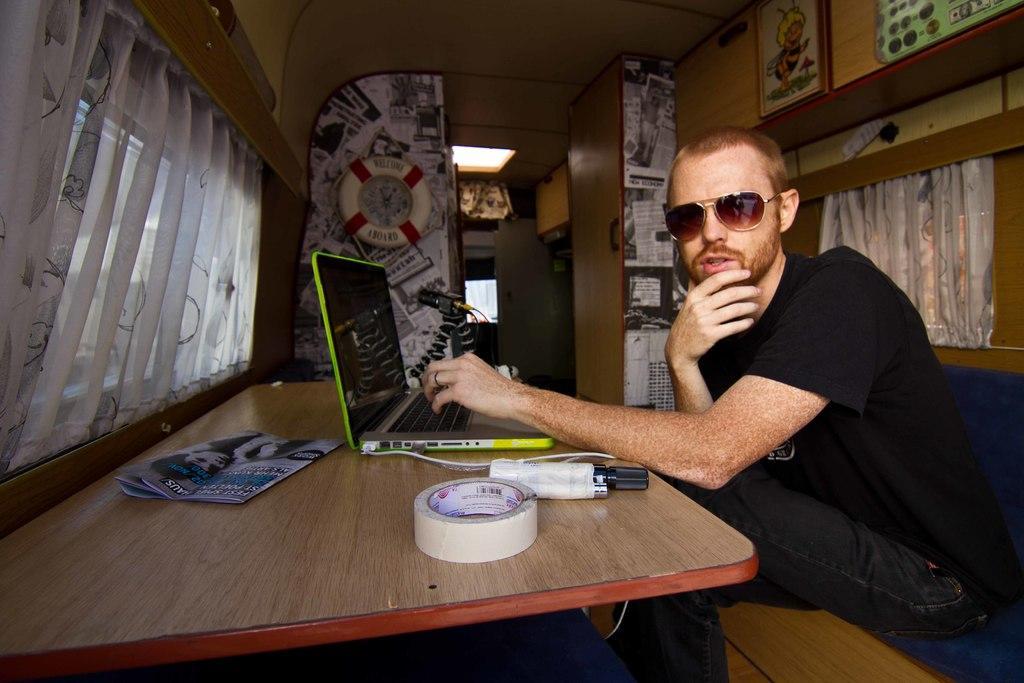How would you summarize this image in a sentence or two? In this picture there is a person wearing black T-shirt is sitting and there is a table in front of him which has a laptop and some other objects on it and there is a white curtain in the left corner and there is a door and some other objects in the background. 